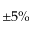Convert formula to latex. <formula><loc_0><loc_0><loc_500><loc_500>\pm 5 \%</formula> 